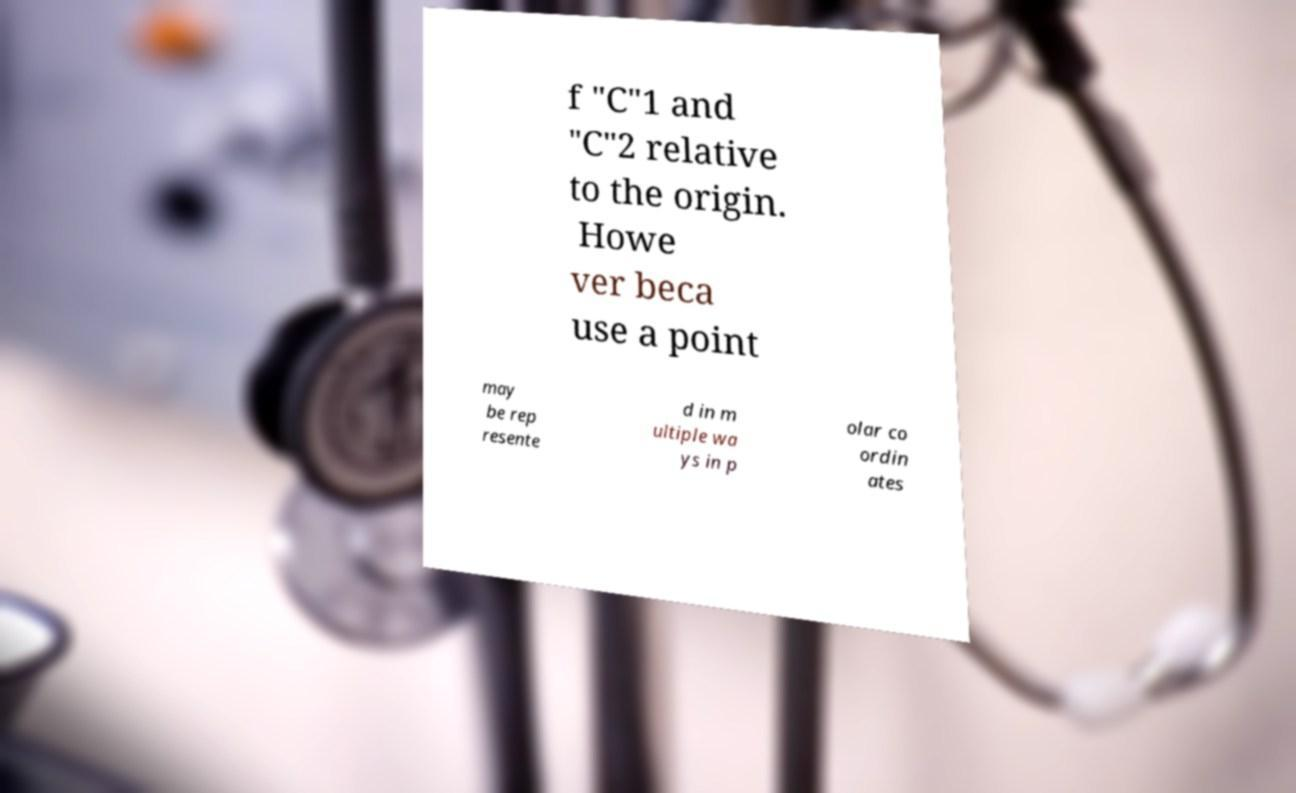For documentation purposes, I need the text within this image transcribed. Could you provide that? f "C"1 and "C"2 relative to the origin. Howe ver beca use a point may be rep resente d in m ultiple wa ys in p olar co ordin ates 